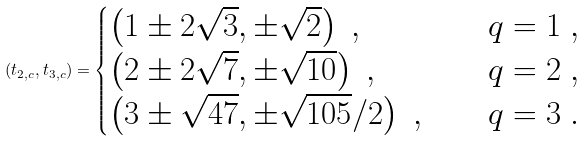<formula> <loc_0><loc_0><loc_500><loc_500>( t _ { 2 , c } , t _ { 3 , c } ) = \begin{cases} \left ( 1 \pm 2 \sqrt { 3 } , \pm \sqrt { 2 } \right ) \ , \quad & q = 1 \ , \\ \left ( 2 \pm 2 \sqrt { 7 } , \pm \sqrt { 1 0 } \right ) \ , \quad & q = 2 \ , \\ \left ( 3 \pm \sqrt { 4 7 } , \pm \sqrt { 1 0 5 } / 2 \right ) \ , \quad & q = 3 \ . \end{cases}</formula> 